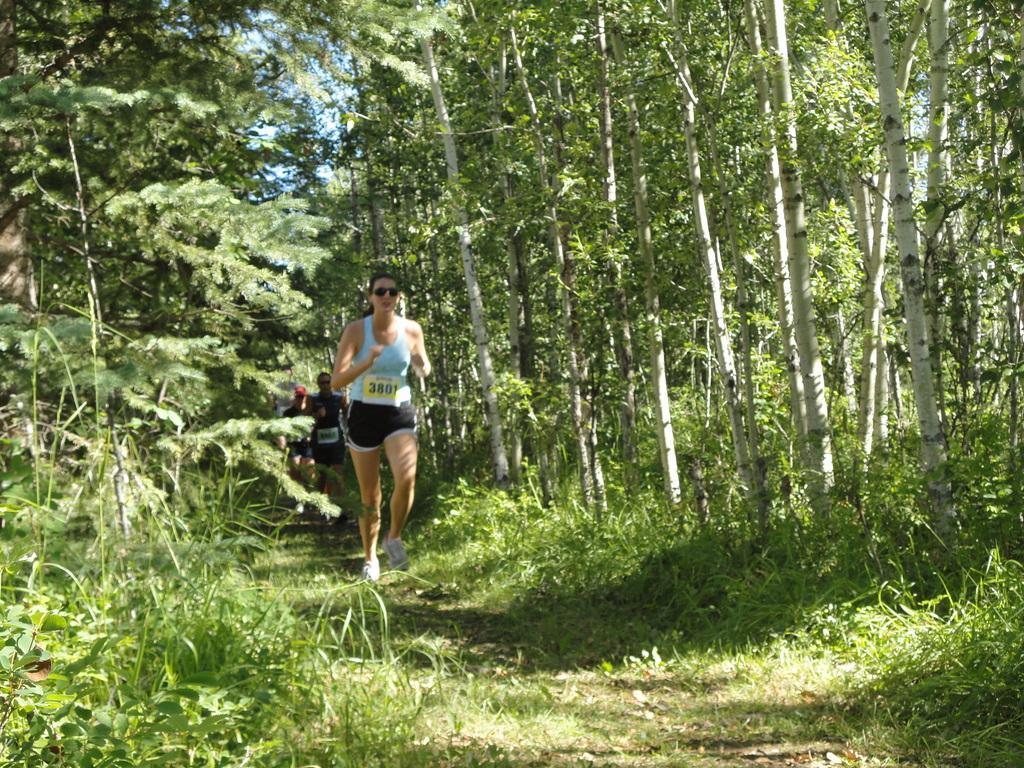Can you describe this image briefly? In this picture there are group of people running and there are trees. At the top there is sky. At the bottom there is grass. 